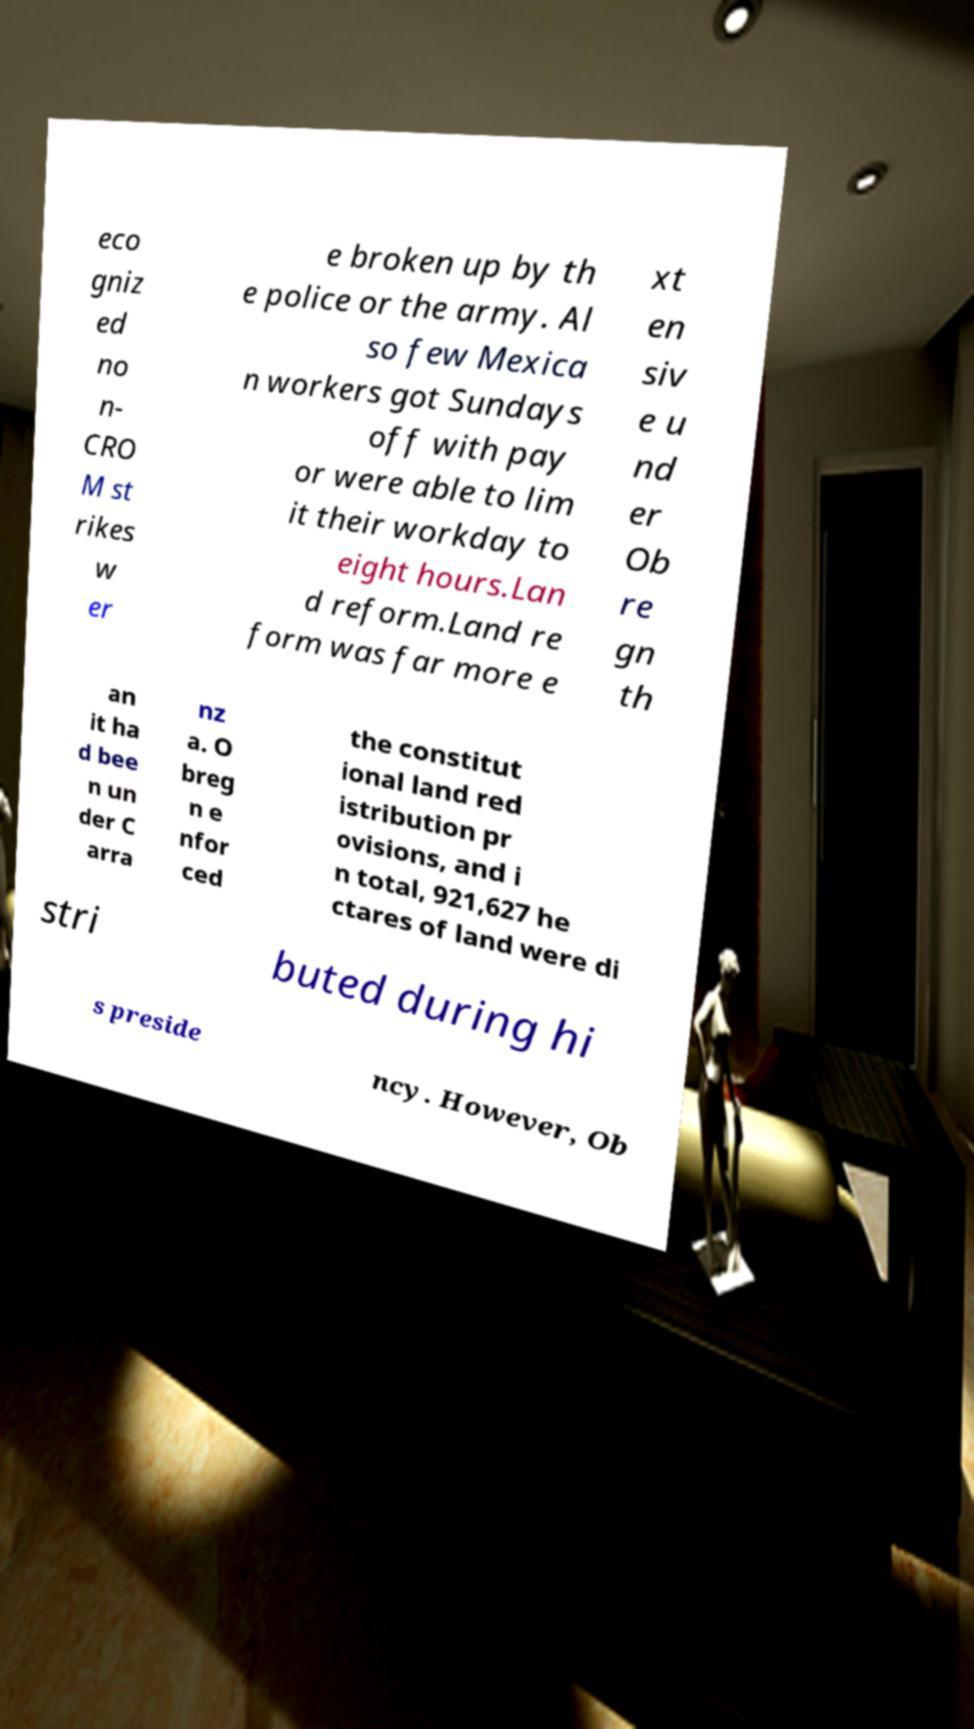Could you assist in decoding the text presented in this image and type it out clearly? eco gniz ed no n- CRO M st rikes w er e broken up by th e police or the army. Al so few Mexica n workers got Sundays off with pay or were able to lim it their workday to eight hours.Lan d reform.Land re form was far more e xt en siv e u nd er Ob re gn th an it ha d bee n un der C arra nz a. O breg n e nfor ced the constitut ional land red istribution pr ovisions, and i n total, 921,627 he ctares of land were di stri buted during hi s preside ncy. However, Ob 